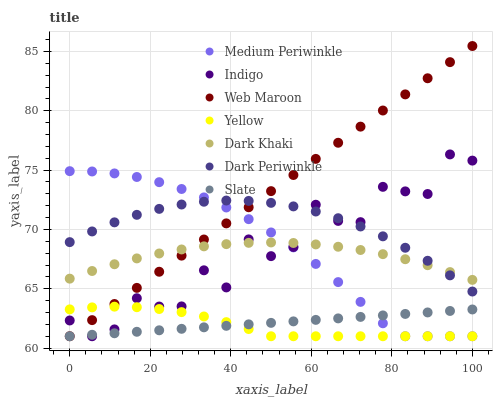Does Yellow have the minimum area under the curve?
Answer yes or no. Yes. Does Web Maroon have the maximum area under the curve?
Answer yes or no. Yes. Does Slate have the minimum area under the curve?
Answer yes or no. No. Does Slate have the maximum area under the curve?
Answer yes or no. No. Is Slate the smoothest?
Answer yes or no. Yes. Is Indigo the roughest?
Answer yes or no. Yes. Is Web Maroon the smoothest?
Answer yes or no. No. Is Web Maroon the roughest?
Answer yes or no. No. Does Indigo have the lowest value?
Answer yes or no. Yes. Does Dark Khaki have the lowest value?
Answer yes or no. No. Does Web Maroon have the highest value?
Answer yes or no. Yes. Does Slate have the highest value?
Answer yes or no. No. Is Slate less than Dark Periwinkle?
Answer yes or no. Yes. Is Dark Khaki greater than Slate?
Answer yes or no. Yes. Does Dark Khaki intersect Dark Periwinkle?
Answer yes or no. Yes. Is Dark Khaki less than Dark Periwinkle?
Answer yes or no. No. Is Dark Khaki greater than Dark Periwinkle?
Answer yes or no. No. Does Slate intersect Dark Periwinkle?
Answer yes or no. No. 